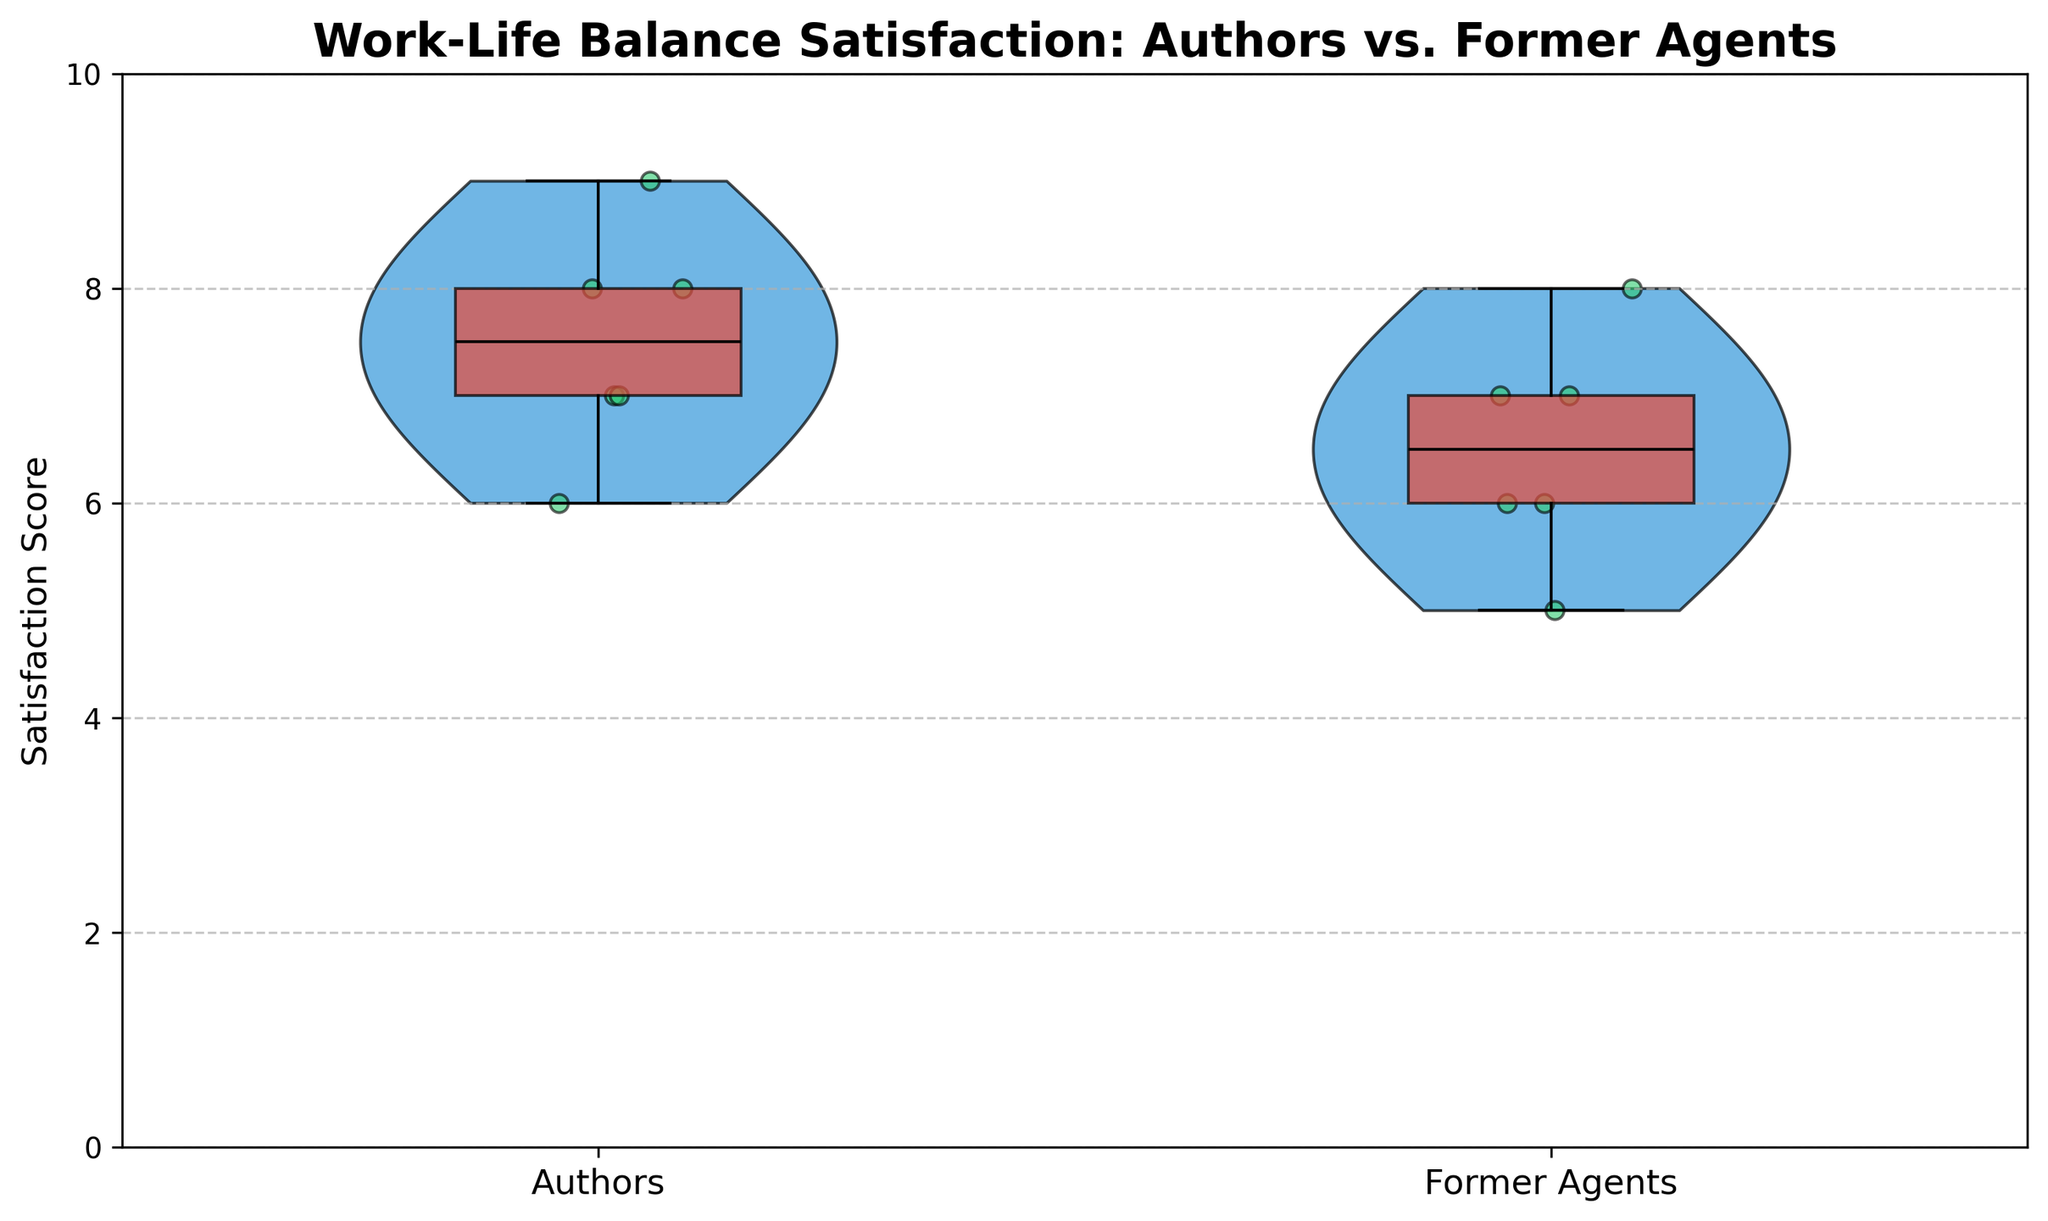What is the title of the plot? The title of the plot is located at the top and reads "Work-Life Balance Satisfaction: Authors vs. Former Agents".
Answer: Work-Life Balance Satisfaction: Authors vs. Former Agents What do the two categories on the x-axis represent? The x-axis categories represent the two groups being compared: "Authors" and "Former Agents".
Answer: Authors and Former Agents What is the maximum satisfaction score on the y-axis? The y-axis is labeled with scores ranging from 0 to 10, with 10 being the maximum satisfaction score shown.
Answer: 10 Which group has the widest range of satisfaction scores? By observing the spread of the violin plots, the group with the widest range (from 5 to 8) is the Former Agents. This can be seen by the overall shape and spread of their distribution.
Answer: Former Agents What is the median satisfaction score for Authors? The median satisfaction score for the Authors is indicated by the black line inside the red box. It is 7.
Answer: 7 What are the minimum and maximum scores for Former Agents? The box plot within the violin plot for Former Agents shows the minimum score is 5 and the maximum score is 8.
Answer: Minimum: 5, Maximum: 8 Describe the shape of the violin plot for Authors. The violin plot for Authors has a relatively smooth and even distribution around the satisfaction scores of 6, 7, and 8, indicating these scores are more common.
Answer: Smooth and even distribution How does the IQR (Interquartile Range) of Authors compare to Former Agents? The IQR, represented by the width of the red box, shows that Authors have their IQR between 7 and 8, which is narrower compared to the Former Agents' IQR between 6 and 7.5.
Answer: Authors have a narrower IQR Which group has more individual data points plotted within the 6 to 7 satisfaction range? By counting the individual points within the 6 to 7 satisfaction range, Former Agents have more points (3) in this range compared to Authors (2).
Answer: Former Agents Are there any outliers in either group? The individual scatter points do not show any scores that deviate significantly from their respective distributions, indicating there are no outliers.
Answer: No 